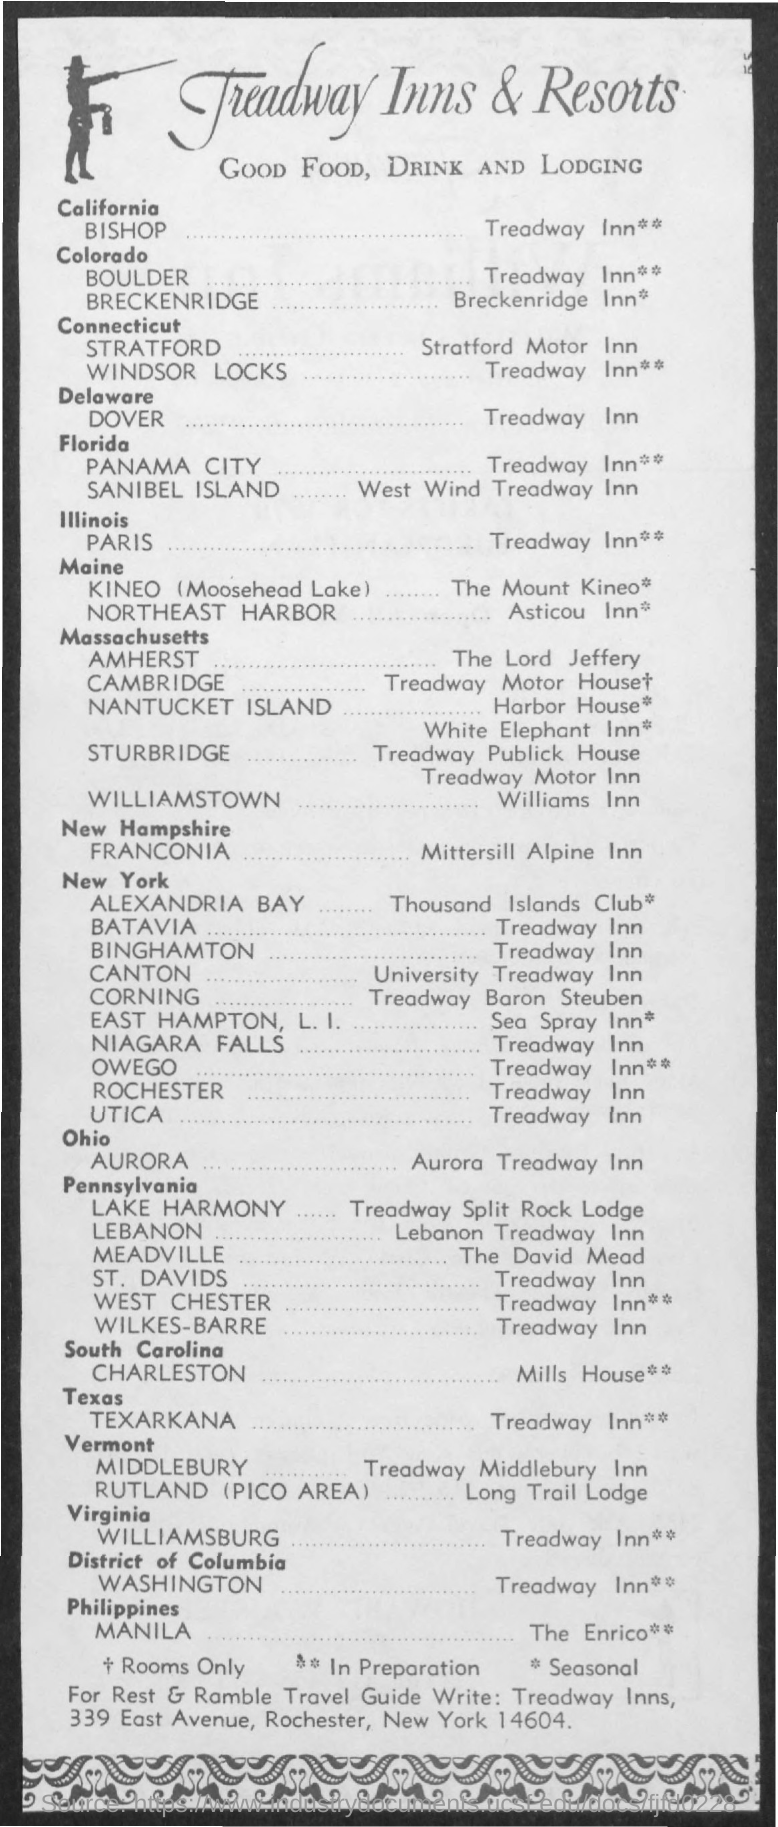What is the name of the resort ?
Make the answer very short. Treadway Inns & Resorts. 